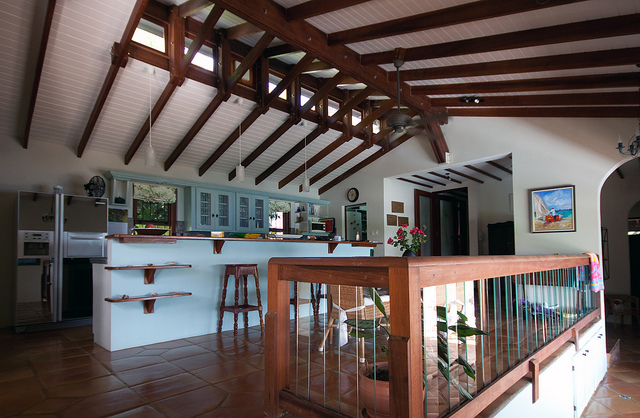<image>Where are the pumpkins located? There are no pumpkins in the image. However, they might be located behind the counter or outside. Where are the pumpkins located? The pumpkins are located behind the counter. 